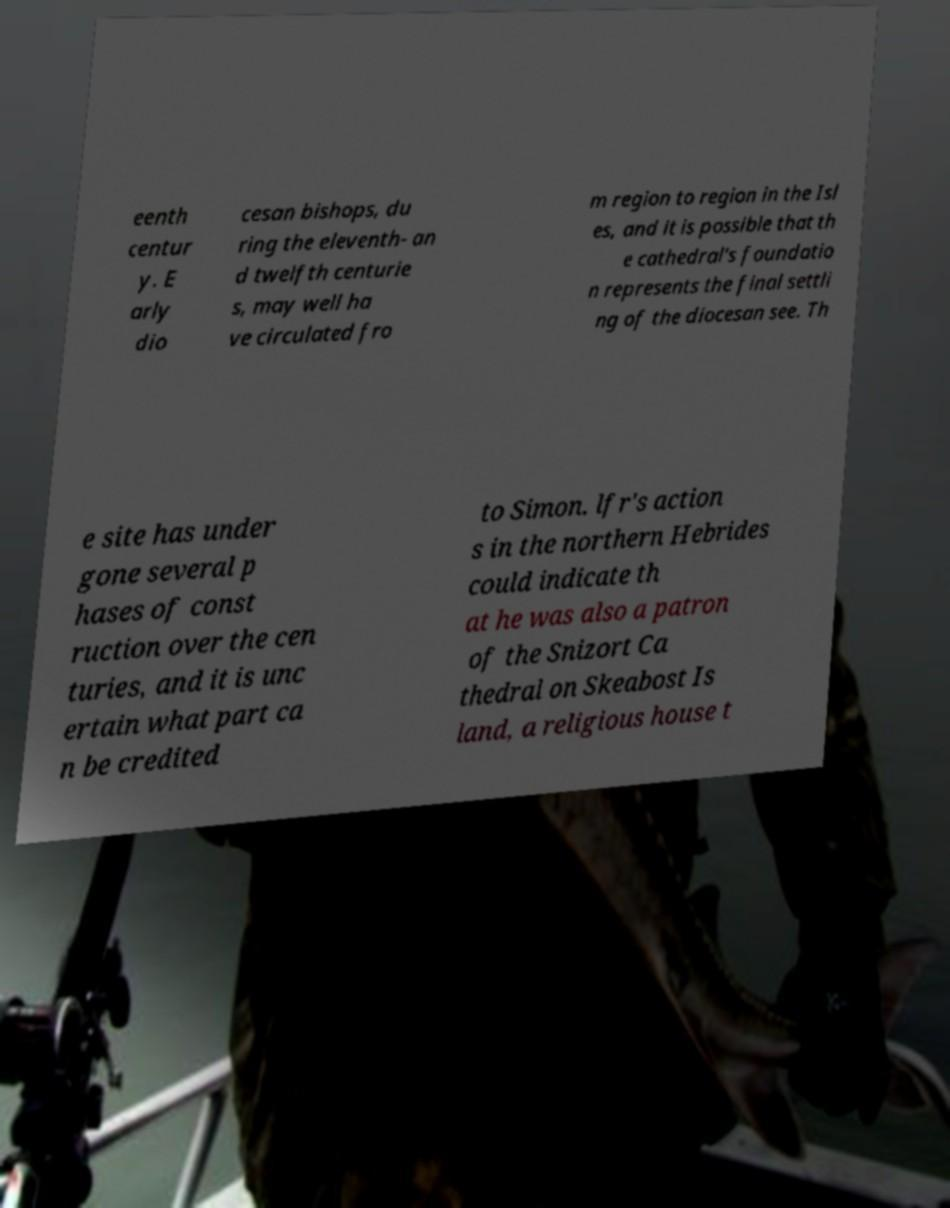Please read and relay the text visible in this image. What does it say? eenth centur y. E arly dio cesan bishops, du ring the eleventh- an d twelfth centurie s, may well ha ve circulated fro m region to region in the Isl es, and it is possible that th e cathedral's foundatio n represents the final settli ng of the diocesan see. Th e site has under gone several p hases of const ruction over the cen turies, and it is unc ertain what part ca n be credited to Simon. lfr's action s in the northern Hebrides could indicate th at he was also a patron of the Snizort Ca thedral on Skeabost Is land, a religious house t 